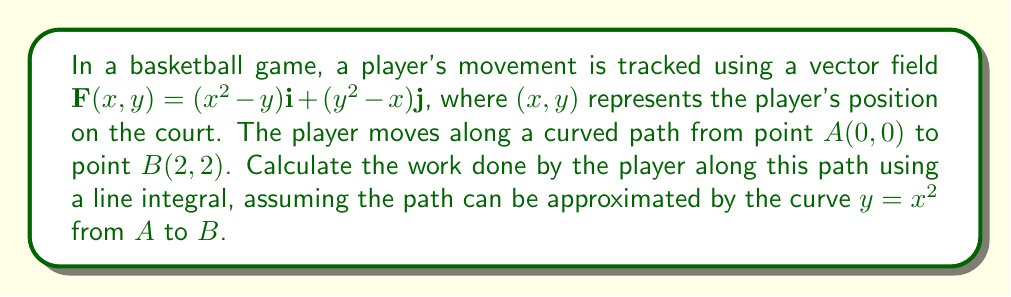Could you help me with this problem? To solve this problem, we need to use the line integral of a vector field along a curve. The steps are as follows:

1) The line integral is given by:

   $$\int_C \mathbf{F} \cdot d\mathbf{r} = \int_a^b \mathbf{F}(r(t)) \cdot \mathbf{r}'(t) dt$$

2) We're given that the path is $y = x^2$, so we can parameterize it as:
   
   $x = t$, $y = t^2$, where $0 \leq t \leq 2$

3) The vector field is $\mathbf{F}(x,y) = (x^2 - y)\mathbf{i} + (y^2 - x)\mathbf{j}$

4) Along our path, this becomes:
   
   $\mathbf{F}(t,t^2) = (t^2 - t^2)\mathbf{i} + ((t^2)^2 - t)\mathbf{j} = (t^4 - t)\mathbf{j}$

5) The derivative of our path is:
   
   $\mathbf{r}'(t) = \mathbf{i} + 2t\mathbf{j}$

6) Now we can set up our integral:

   $$\int_0^2 [(t^4 - t)\mathbf{j}] \cdot [\mathbf{i} + 2t\mathbf{j}] dt$$

7) Simplifying the dot product:

   $$\int_0^2 2t(t^4 - t) dt = \int_0^2 2(t^5 - t^2) dt$$

8) Integrating:

   $$\left[\frac{2t^6}{6} - \frac{2t^3}{3}\right]_0^2$$

9) Evaluating the limits:

   $$\left(\frac{2(2^6)}{6} - \frac{2(2^3)}{3}\right) - \left(\frac{2(0^6)}{6} - \frac{2(0^3)}{3}\right) = \frac{64}{3} - \frac{16}{3} = 16$$

Therefore, the work done by the player along this path is 16 units.
Answer: 16 units of work 